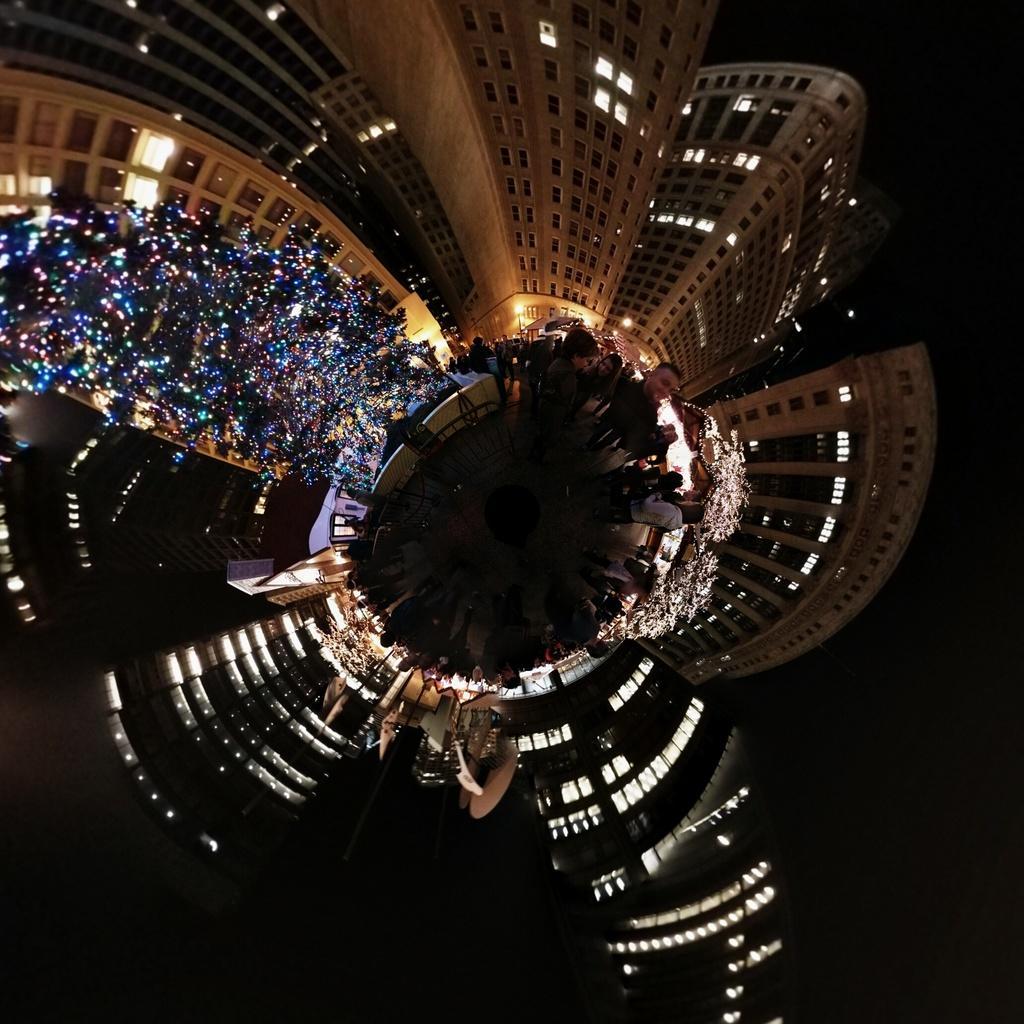In one or two sentences, can you explain what this image depicts? In this image we can see few buildings with lights, an object looks like tree with lights and few people. 